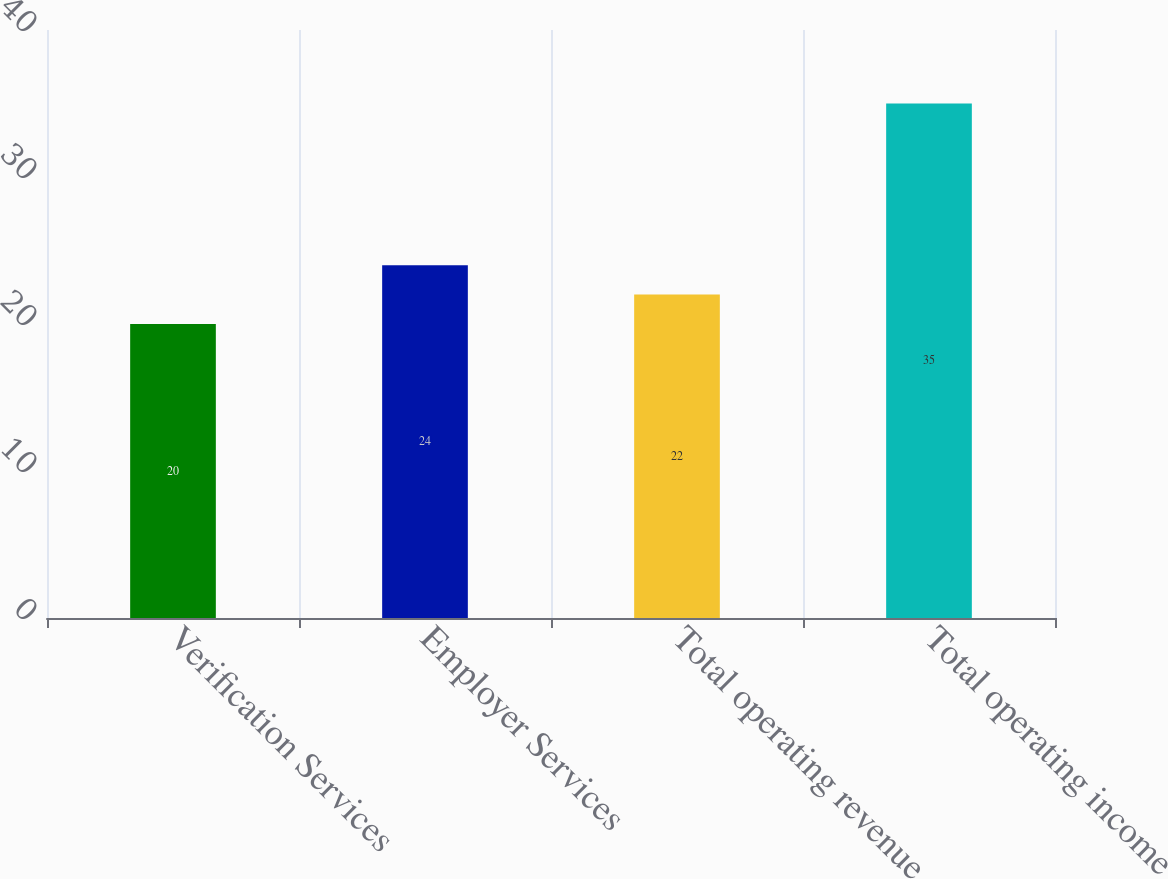Convert chart to OTSL. <chart><loc_0><loc_0><loc_500><loc_500><bar_chart><fcel>Verification Services<fcel>Employer Services<fcel>Total operating revenue<fcel>Total operating income<nl><fcel>20<fcel>24<fcel>22<fcel>35<nl></chart> 